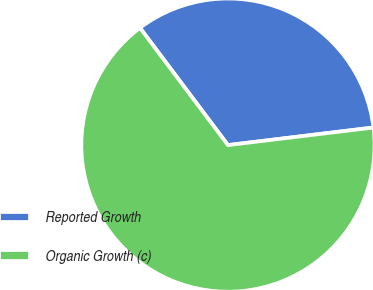Convert chart. <chart><loc_0><loc_0><loc_500><loc_500><pie_chart><fcel>Reported Growth<fcel>Organic Growth (c)<nl><fcel>33.33%<fcel>66.67%<nl></chart> 